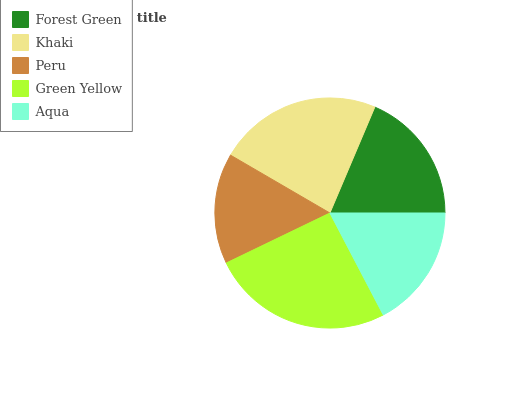Is Peru the minimum?
Answer yes or no. Yes. Is Green Yellow the maximum?
Answer yes or no. Yes. Is Khaki the minimum?
Answer yes or no. No. Is Khaki the maximum?
Answer yes or no. No. Is Khaki greater than Forest Green?
Answer yes or no. Yes. Is Forest Green less than Khaki?
Answer yes or no. Yes. Is Forest Green greater than Khaki?
Answer yes or no. No. Is Khaki less than Forest Green?
Answer yes or no. No. Is Forest Green the high median?
Answer yes or no. Yes. Is Forest Green the low median?
Answer yes or no. Yes. Is Peru the high median?
Answer yes or no. No. Is Green Yellow the low median?
Answer yes or no. No. 